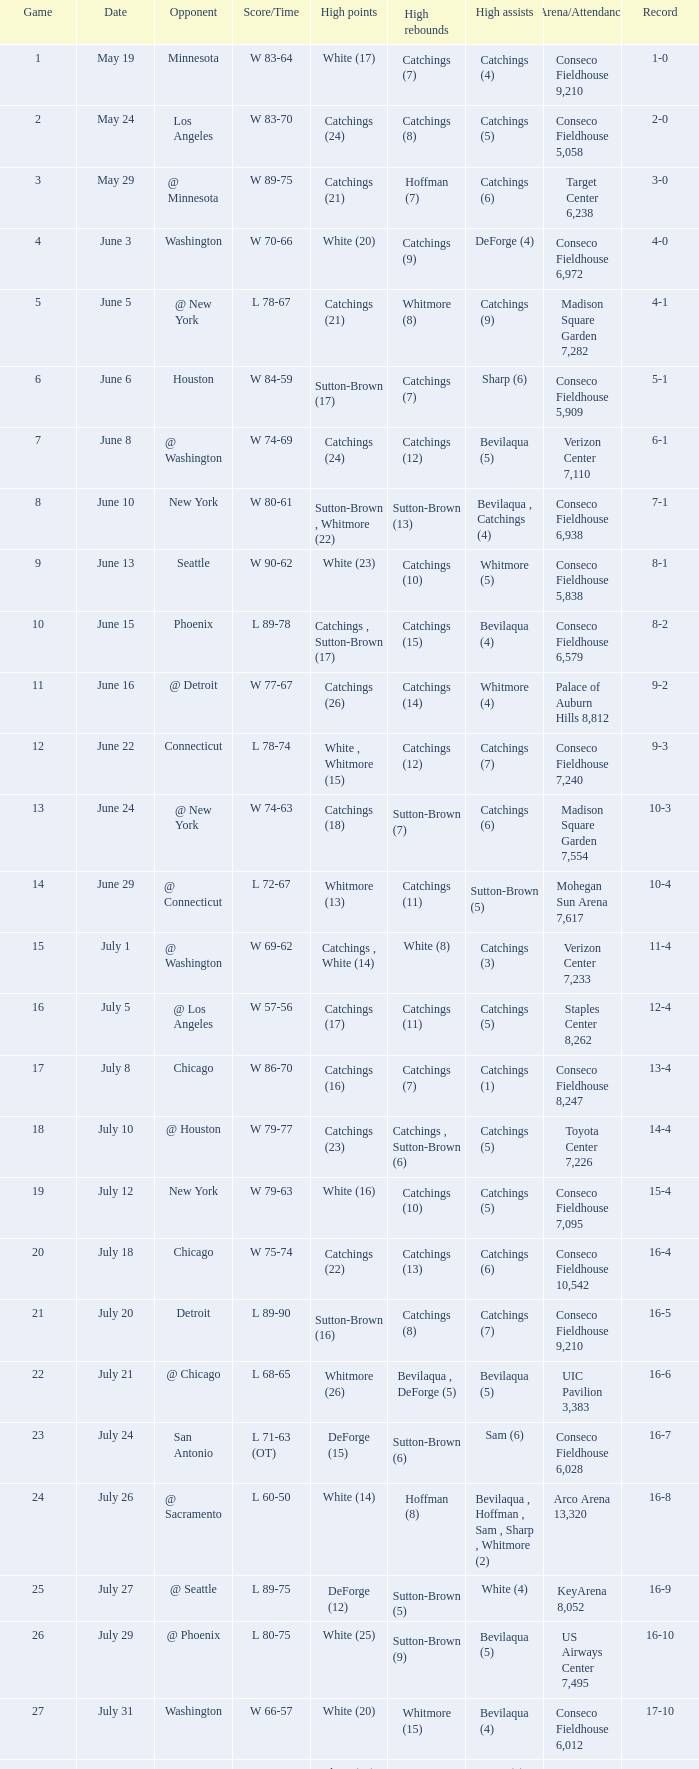Name the date where score time is w 74-63 June 24. 